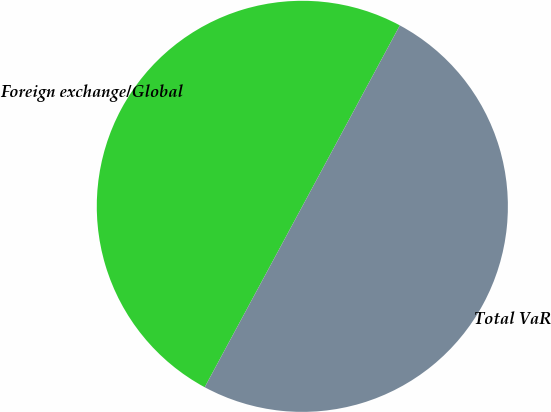<chart> <loc_0><loc_0><loc_500><loc_500><pie_chart><fcel>Foreign exchange/Global<fcel>Total VaR<nl><fcel>49.99%<fcel>50.01%<nl></chart> 